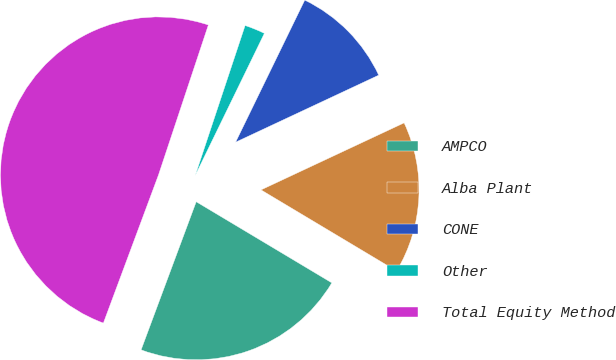Convert chart. <chart><loc_0><loc_0><loc_500><loc_500><pie_chart><fcel>AMPCO<fcel>Alba Plant<fcel>CONE<fcel>Other<fcel>Total Equity Method<nl><fcel>22.09%<fcel>15.55%<fcel>10.82%<fcel>2.1%<fcel>49.44%<nl></chart> 